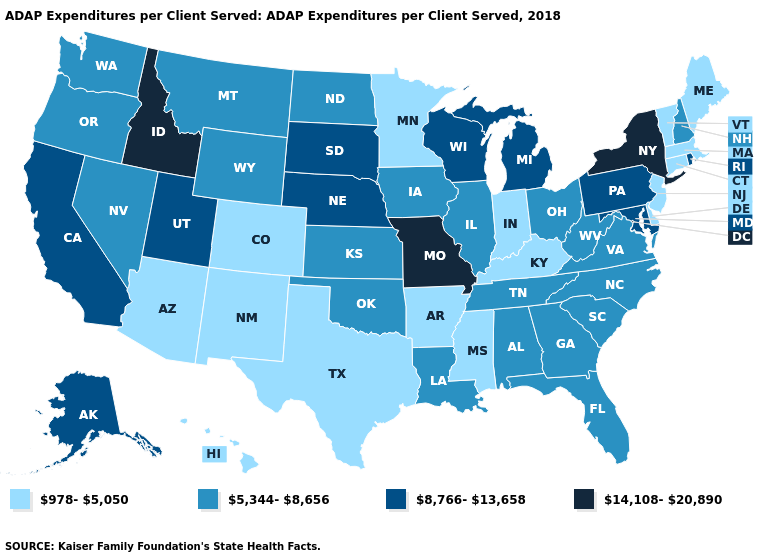Name the states that have a value in the range 978-5,050?
Quick response, please. Arizona, Arkansas, Colorado, Connecticut, Delaware, Hawaii, Indiana, Kentucky, Maine, Massachusetts, Minnesota, Mississippi, New Jersey, New Mexico, Texas, Vermont. What is the highest value in the Northeast ?
Short answer required. 14,108-20,890. Does the map have missing data?
Concise answer only. No. Name the states that have a value in the range 14,108-20,890?
Keep it brief. Idaho, Missouri, New York. What is the value of Georgia?
Short answer required. 5,344-8,656. Among the states that border Wisconsin , which have the lowest value?
Concise answer only. Minnesota. Name the states that have a value in the range 978-5,050?
Concise answer only. Arizona, Arkansas, Colorado, Connecticut, Delaware, Hawaii, Indiana, Kentucky, Maine, Massachusetts, Minnesota, Mississippi, New Jersey, New Mexico, Texas, Vermont. Does Louisiana have the same value as Utah?
Quick response, please. No. What is the value of West Virginia?
Short answer required. 5,344-8,656. What is the value of North Dakota?
Quick response, please. 5,344-8,656. Which states hav the highest value in the Northeast?
Quick response, please. New York. What is the value of Minnesota?
Quick response, please. 978-5,050. Name the states that have a value in the range 978-5,050?
Keep it brief. Arizona, Arkansas, Colorado, Connecticut, Delaware, Hawaii, Indiana, Kentucky, Maine, Massachusetts, Minnesota, Mississippi, New Jersey, New Mexico, Texas, Vermont. Does Maryland have the highest value in the South?
Write a very short answer. Yes. Does Pennsylvania have a lower value than Illinois?
Give a very brief answer. No. 